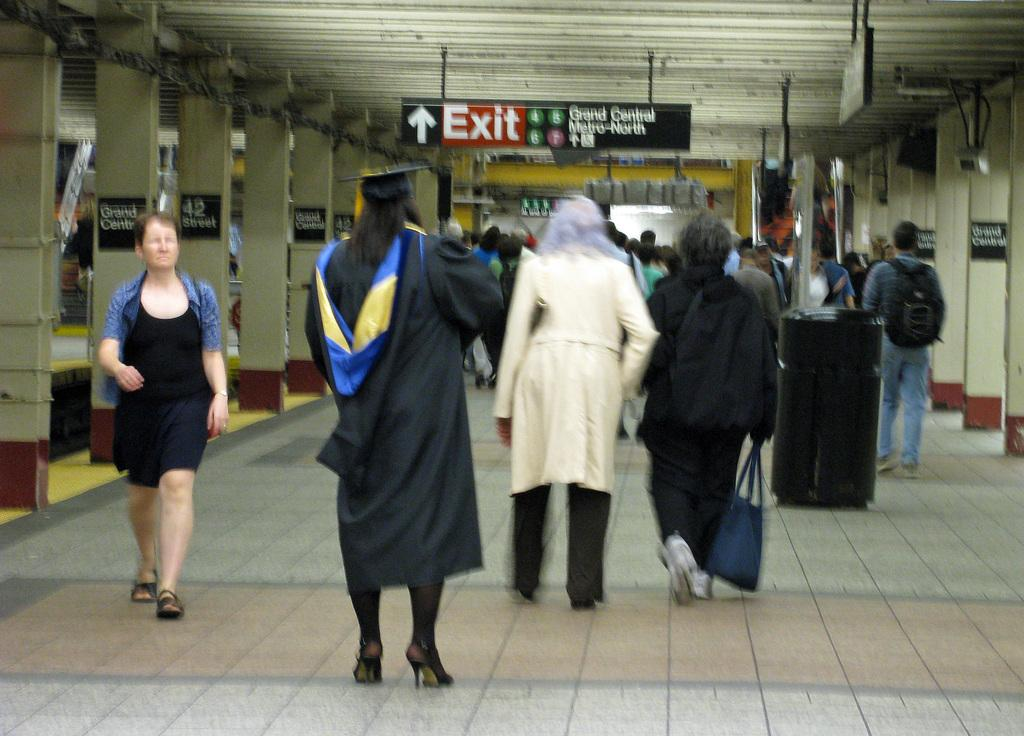What is the main focus of the image? The main focus of the image is the people in the center. What can be seen at the top side of the image? There is an exit board at the top side of the image. What architectural features are present on the sides of the image? There are pillars on both the right and left sides of the image. How many snails can be seen crawling on the pillars in the image? There are no snails present in the image; the pillars are the only visible objects on the sides. 